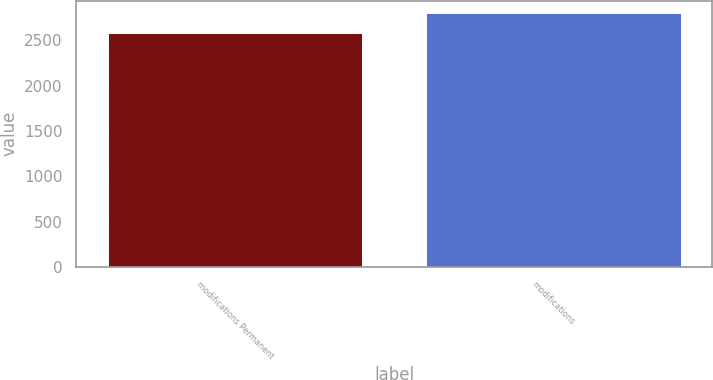Convert chart. <chart><loc_0><loc_0><loc_500><loc_500><bar_chart><fcel>modifications Permanent<fcel>modifications<nl><fcel>2581<fcel>2798<nl></chart> 